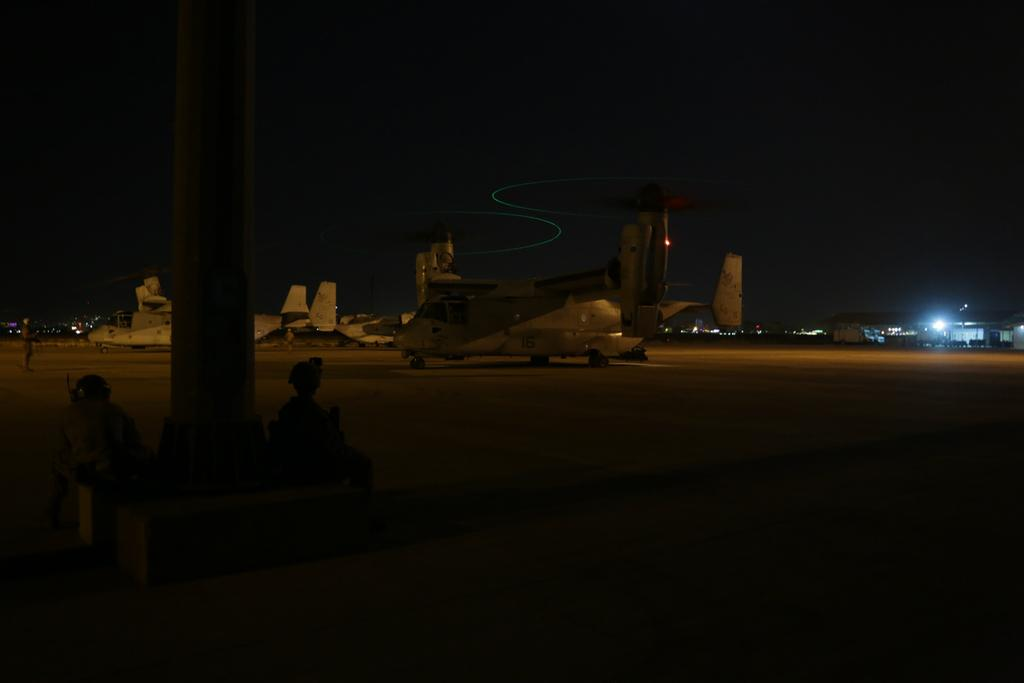What is the main subject of the image? The main subject of the image is airplanes. What else can be seen on the ground in the image? There are vehicles on the runway in the image. What is visible in the background of the image? There are many buildings and lights in the background of the image. What can be inferred about the time the image was taken? The image was clicked in the dark. What type of string can be seen connecting the airplanes in the image? There is no string connecting the airplanes in the image. What is the best way to reach the point where the airplanes are parked in the image? The image does not provide information on how to reach the airplanes, as it is a still photograph. 